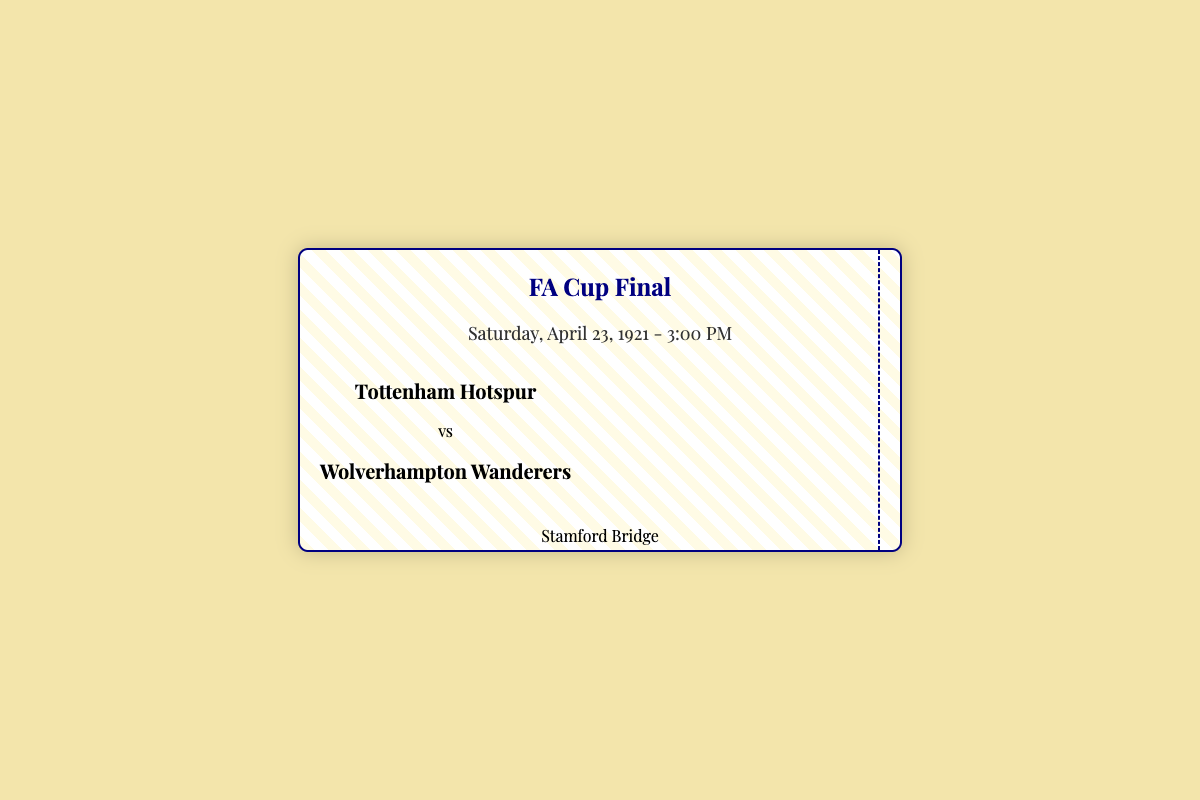What is the date of the match? The date is presented prominently in the ticket as "Saturday, April 23, 1921."
Answer: Saturday, April 23, 1921 What time did the match start? The match time is indicated in the ticket under the date as "3:00 PM."
Answer: 3:00 PM Which teams played in the final? The names of the teams are listed in the ticket, with Tottenham Hotspur and Wolverhampton Wanderers.
Answer: Tottenham Hotspur vs Wolverhampton Wanderers What was the final score of the match? The final score is detailed in the ticket's footer, stating "Tottenham Hotspur 1 - 0 Wolverhampton Wanderers."
Answer: Tottenham Hotspur 1 - 0 Wolverhampton Wanderers Who scored the winning goal? The ticket mentions that "Jimmy Dimmock scored the winning goal in the 55th minute."
Answer: Jimmy Dimmock Where was the match held? The venue is listed on the ticket as "Stamford Bridge, Fulham Road, London."
Answer: Stamford Bridge How many goals were scored in total? The final score indicates that there was one goal scored in the match.
Answer: 1 What type of event is this ticket for? The ticket is specifically for the "FA Cup Final," as stated in the title.
Answer: FA Cup Final What design element is used in the background of the ticket? The background features a repeating linear gradient, which adds a unique visual aspect to the ticket design.
Answer: Repeating linear gradient 